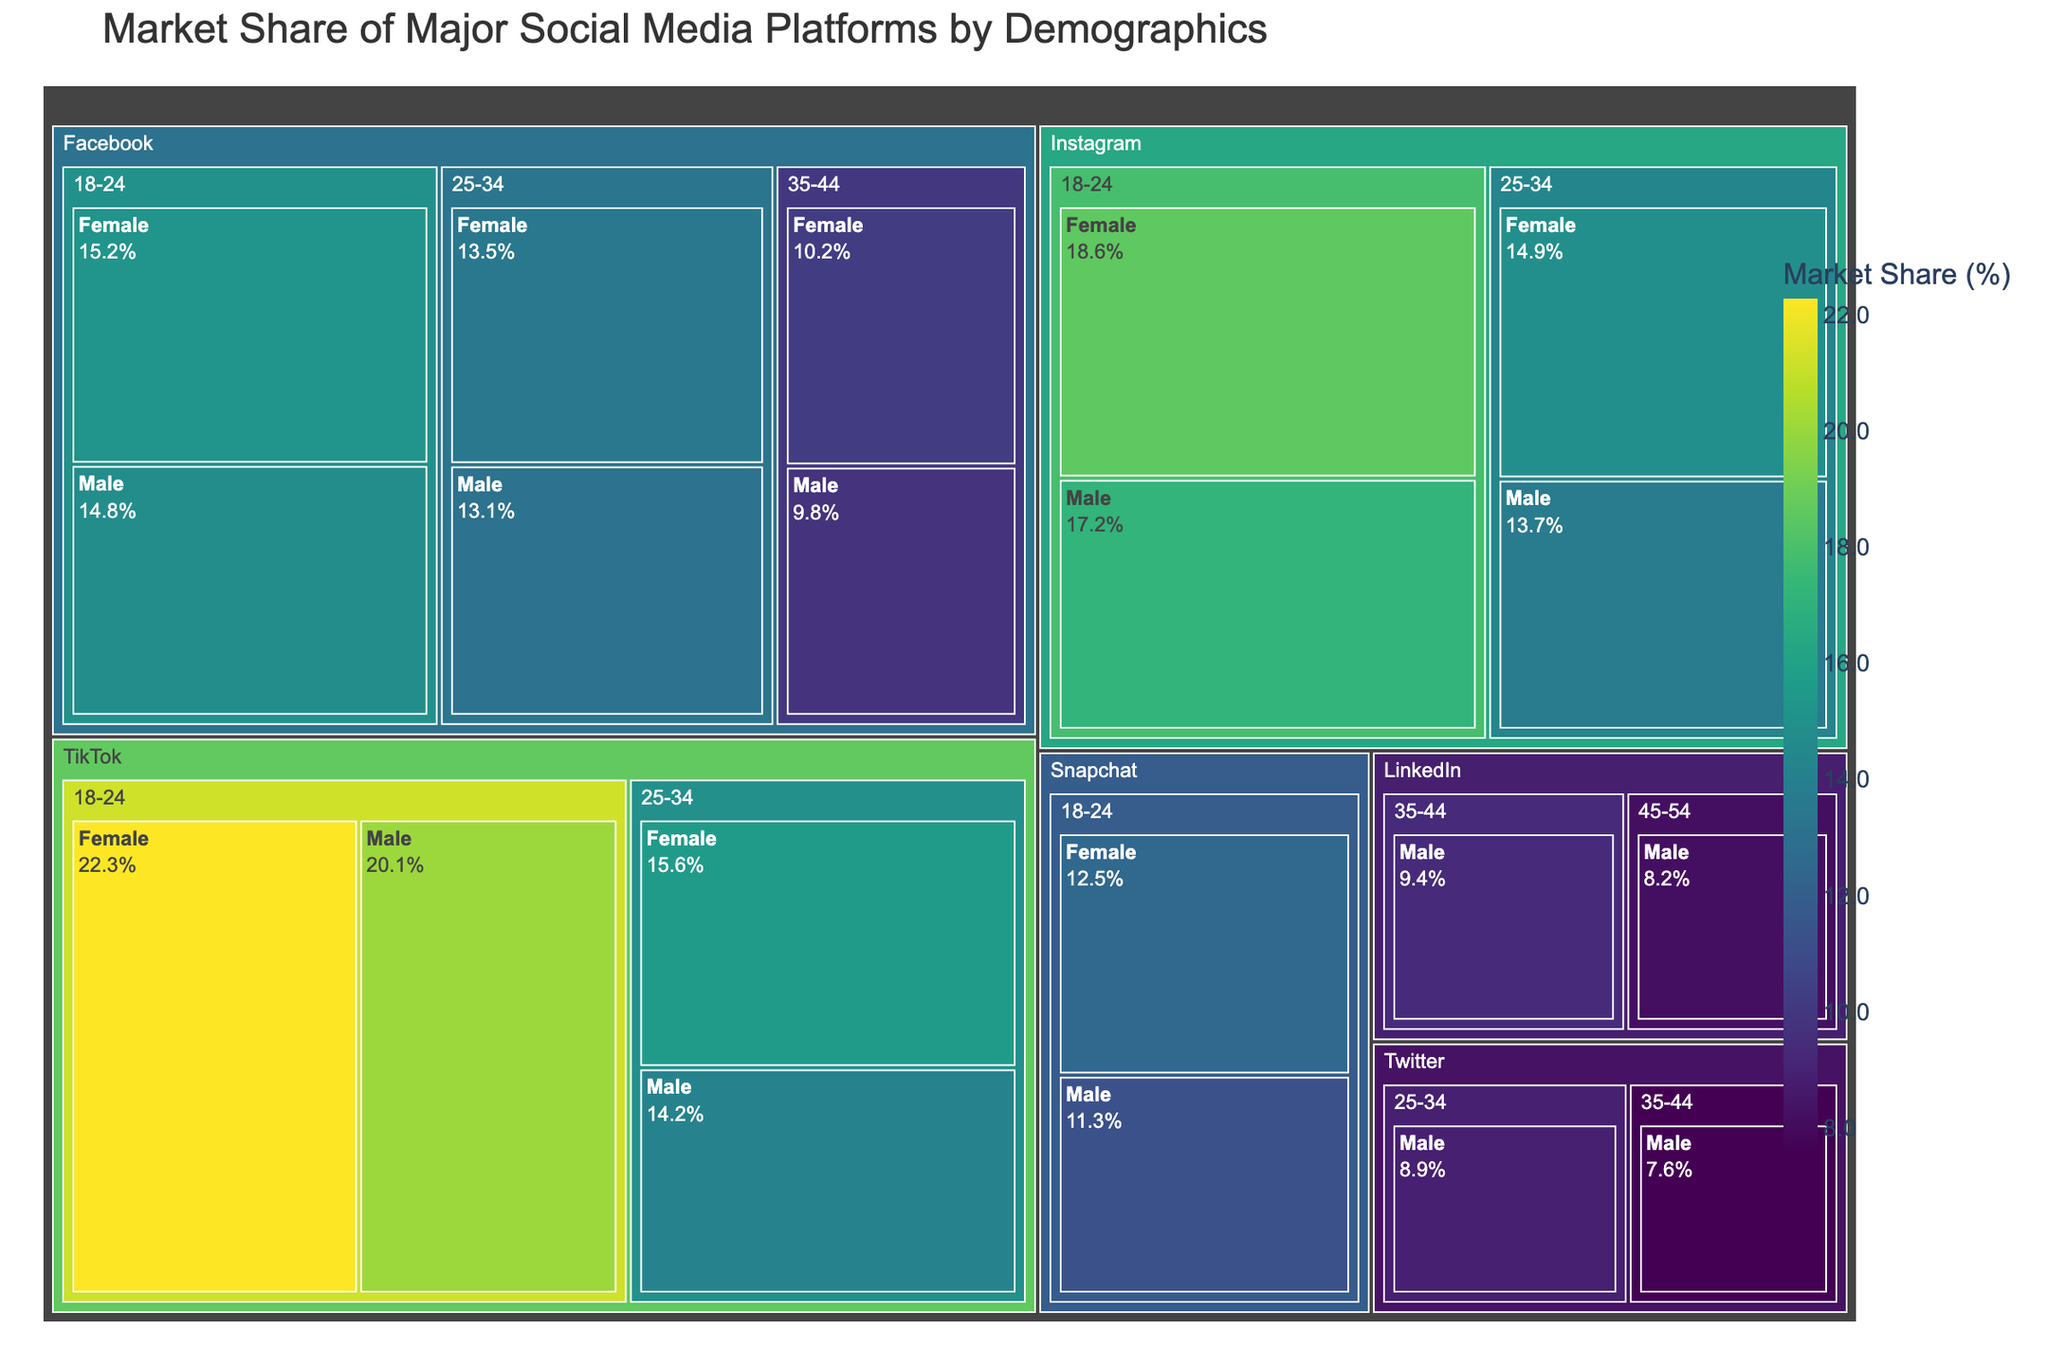What is the title of the treemap? The title is usually at the top of the plot and provides a summary of what the plot displays. Here, it shows "Market Share of Major Social Media Platforms by Demographics".
Answer: Market Share of Major Social Media Platforms by Demographics Which platform has the largest market share among females aged 18-24? Identify the platform with the highest value in the "Female" category within the "18-24" age group. TikTok has the highest share with 22.3%.
Answer: TikTok Between Facebook and Instagram, which has a larger market share among males aged 25-34? Compare the market share values of Facebook and Instagram for males aged 25-34. Instagram has 13.7% whereas Facebook has 13.1%.
Answer: Instagram What is the total market share of TikTok among females aged 18-34? Add the market share values of TikTok for females aged 18-24 and 25-34: 22.3% + 15.6% = 37.9%.
Answer: 37.9% How does the market share of Snapchat for males aged 18-24 compare to Facebook for females aged 18-24? Compare the market share values: Snapchat for males aged 18-24 has 11.3%, while Facebook for females aged 18-24 has 15.2%. Facebook has a higher share.
Answer: Facebook has a higher share What is the average market share of Instagram among all gender and age groups listed? Calculate the total market share for all entries of Instagram and then divide by the number of entries: (18.6 + 17.2 + 14.9 + 13.7) / 4 = 16.1%.
Answer: 16.1% Which platform has the smallest market share among males aged 35-44? Identify the platform with the smallest market share for males aged 35-44. In this case, it is Twitter with 7.6%.
Answer: Twitter What is the difference in market share between LinkedIn for males aged 45-54 and Twitter for males aged 35-44? Subtract the market share values: LinkedIn for males aged 45-54 has 8.2%, and Twitter for males aged 35-44 has 7.6%. The difference is 8.2% - 7.6% = 0.6%.
Answer: 0.6% Which gender has a higher market share on TikTok for the age group 18-24? Compare the market share values for males and females aged 18-24 on TikTok. Females have 22.3%, and males have 20.1%, so females have a higher share.
Answer: Female What is the combined market share of Facebook and Instagram for the age group 18-24? Add the market share values of Facebook and Instagram for both genders: (15.2 + 14.8) + (18.6 + 17.2) = 65.8%.
Answer: 65.8% 